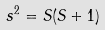Convert formula to latex. <formula><loc_0><loc_0><loc_500><loc_500>s ^ { 2 } = S ( S + 1 )</formula> 